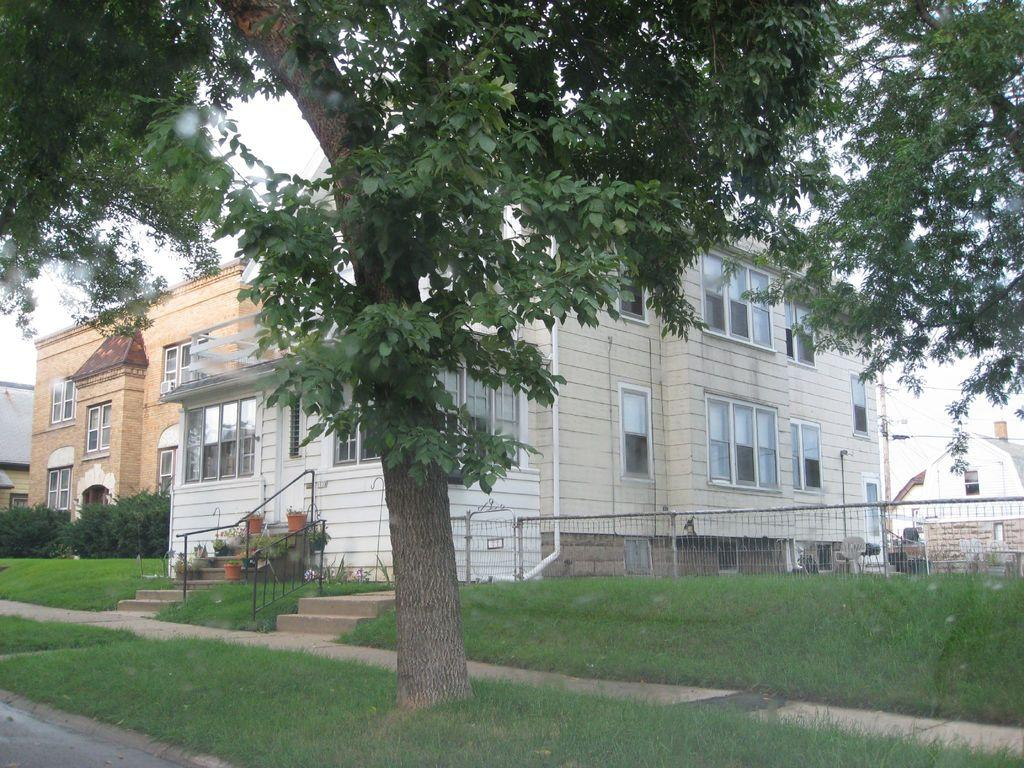What type of structures can be seen in the image? There are buildings in the image. What type of plant is present in the image? There is a tree in the image. What is located on the right side of the image? There is a fence and grass on the right side of the image. What is visible behind the tree in the image? The sky is visible behind the tree. What type of game is being played in the image? There is no game being played in the image; it features buildings, a tree, a fence, grass, and the sky. 